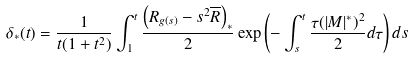<formula> <loc_0><loc_0><loc_500><loc_500>\delta _ { * } ( t ) = \frac { 1 } { t ( 1 + t ^ { 2 } ) } \int _ { 1 } ^ { t } \frac { \left ( R _ { g ( s ) } - s ^ { 2 } \overline { R } \right ) _ { * } } { 2 } \exp \left ( - \int _ { s } ^ { t } \frac { \tau ( | M | ^ { * } ) ^ { 2 } } { 2 } d \tau \right ) d s</formula> 